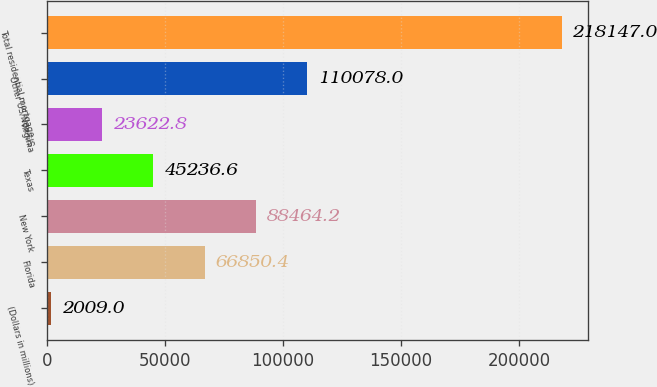<chart> <loc_0><loc_0><loc_500><loc_500><bar_chart><fcel>(Dollars in millions)<fcel>Florida<fcel>New York<fcel>Texas<fcel>Virginia<fcel>Other US/Non-US<fcel>Total residential mortgage<nl><fcel>2009<fcel>66850.4<fcel>88464.2<fcel>45236.6<fcel>23622.8<fcel>110078<fcel>218147<nl></chart> 